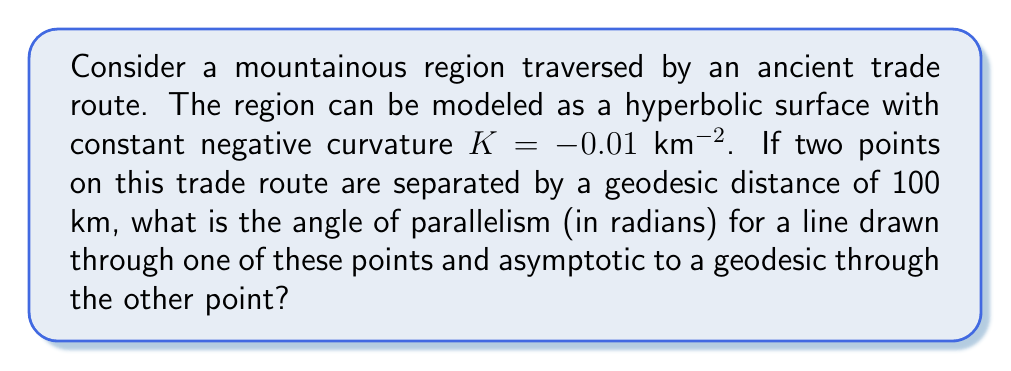Provide a solution to this math problem. To solve this problem, we'll use concepts from hyperbolic geometry:

1) In hyperbolic geometry, the angle of parallelism Π(d) for a distance d is given by the formula:

   $$\Pi(d) = 2 \arctan(e^{-d\sqrt{-K}})$$

2) We're given:
   - Curvature K = -0.01 km^(-2)
   - Distance d = 100 km

3) Let's substitute these values into the formula:

   $$\Pi(100) = 2 \arctan(e^{-100\sqrt{0.01}})$$

4) Simplify inside the square root:
   
   $$\Pi(100) = 2 \arctan(e^{-100 \cdot 0.1})$$

5) Calculate the exponent:
   
   $$\Pi(100) = 2 \arctan(e^{-10})$$

6) Use a calculator to evaluate e^(-10):
   
   $$\Pi(100) = 2 \arctan(0.0000453999)$$

7) Finally, calculate the arctangent and multiply by 2:
   
   $$\Pi(100) = 2 \cdot 0.0000453999 = 0.0000907998$$

The angle of parallelism is approximately 0.0000907998 radians.
Answer: 0.0000907998 radians 